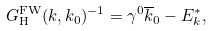<formula> <loc_0><loc_0><loc_500><loc_500>G _ { \text {H} } ^ { \text {FW} } ( k , k _ { 0 } ) ^ { - 1 } = \gamma ^ { 0 } \overline { k } _ { 0 } - E _ { k } ^ { * } ,</formula> 